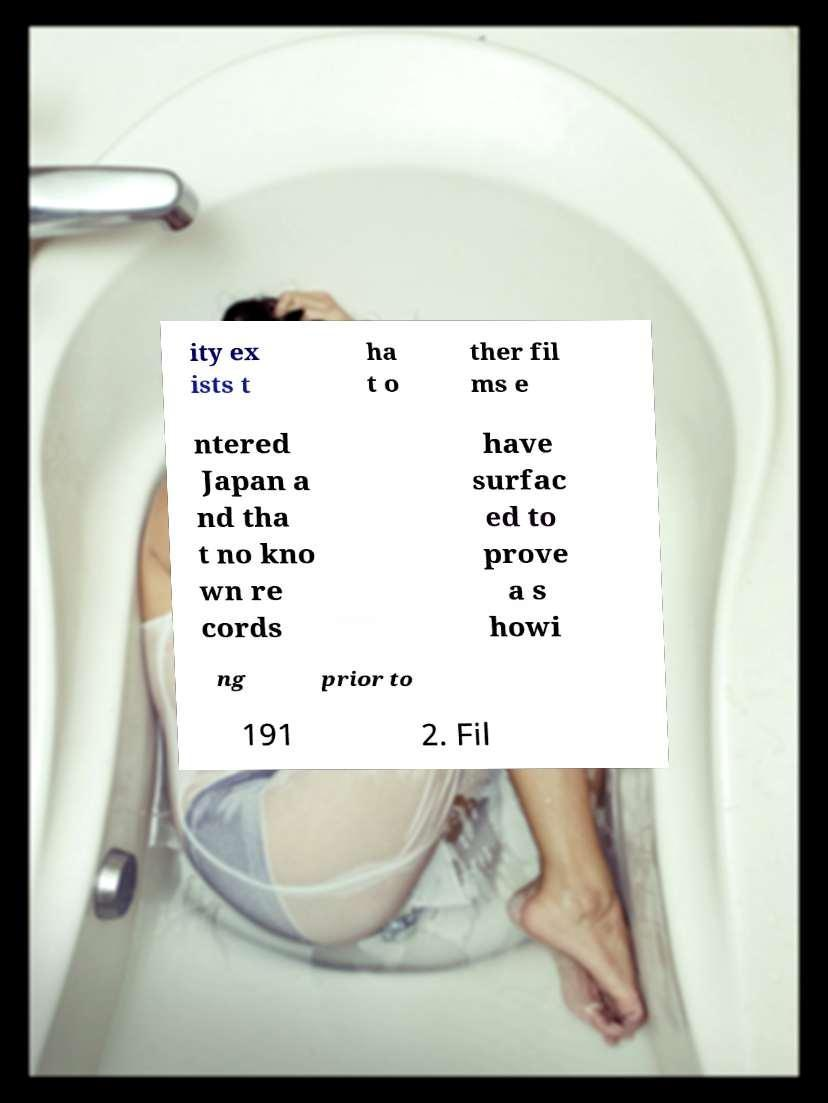Please read and relay the text visible in this image. What does it say? ity ex ists t ha t o ther fil ms e ntered Japan a nd tha t no kno wn re cords have surfac ed to prove a s howi ng prior to 191 2. Fil 